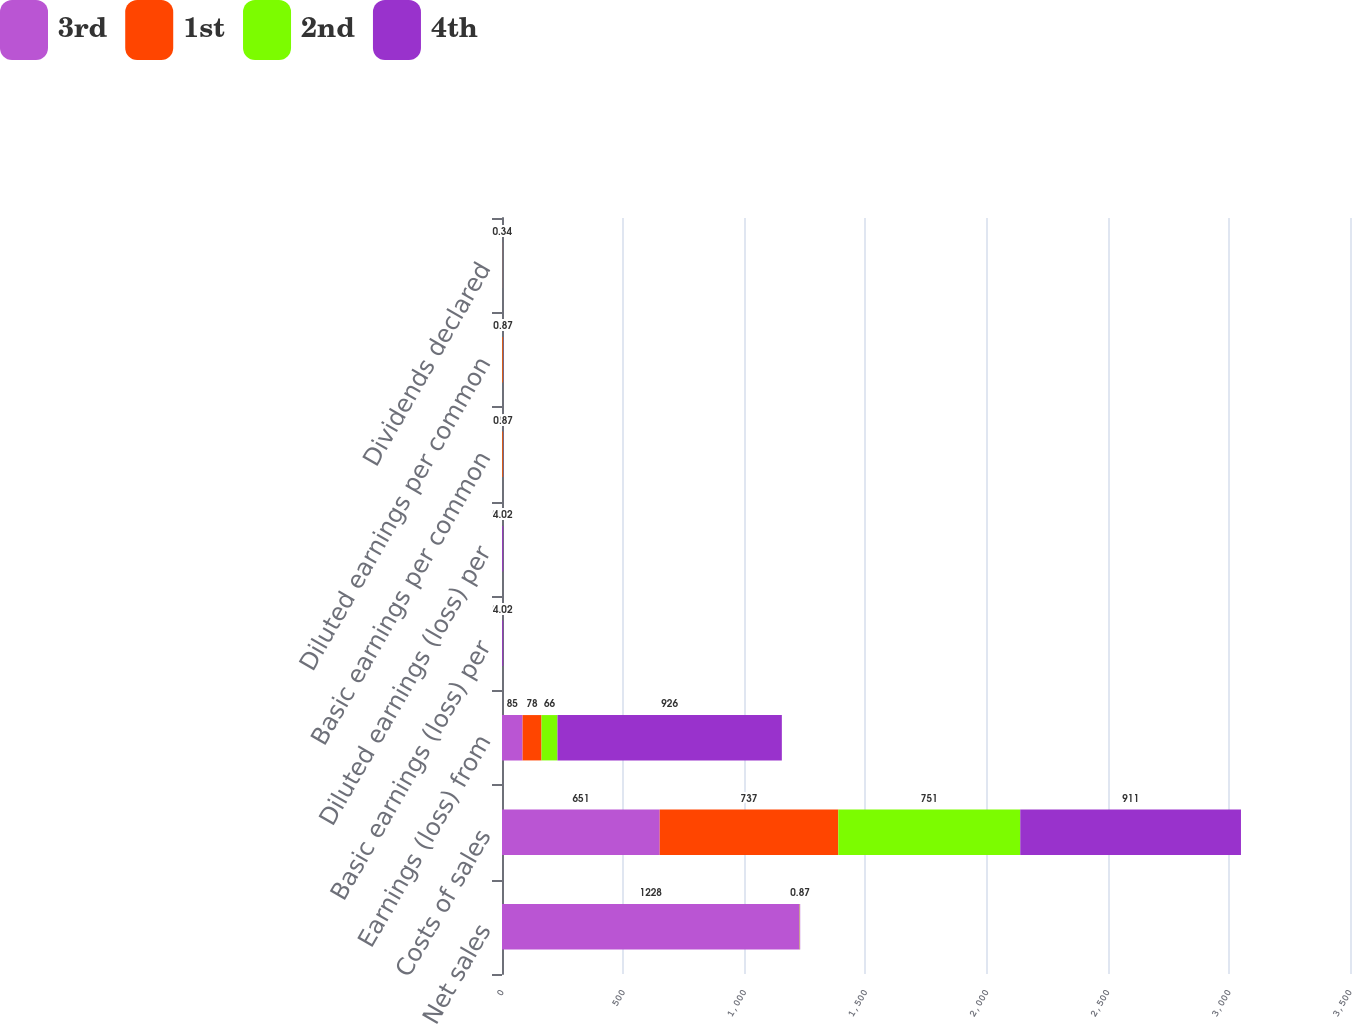Convert chart. <chart><loc_0><loc_0><loc_500><loc_500><stacked_bar_chart><ecel><fcel>Net sales<fcel>Costs of sales<fcel>Earnings (loss) from<fcel>Basic earnings (loss) per<fcel>Diluted earnings (loss) per<fcel>Basic earnings per common<fcel>Diluted earnings per common<fcel>Dividends declared<nl><fcel>3rd<fcel>1228<fcel>651<fcel>85<fcel>0.33<fcel>0.33<fcel>0.5<fcel>0.49<fcel>0.31<nl><fcel>1st<fcel>0.87<fcel>737<fcel>78<fcel>0.31<fcel>0.3<fcel>3.25<fcel>3.22<fcel>0.31<nl><fcel>2nd<fcel>0.87<fcel>751<fcel>66<fcel>0.27<fcel>0.27<fcel>0.6<fcel>0.59<fcel>0.34<nl><fcel>4th<fcel>0.87<fcel>911<fcel>926<fcel>4.02<fcel>4.02<fcel>0.87<fcel>0.87<fcel>0.34<nl></chart> 